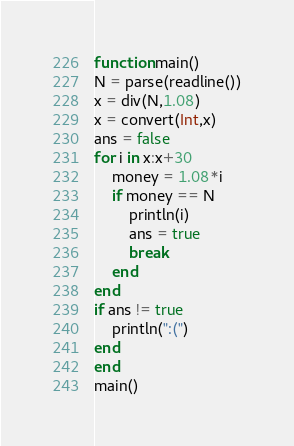<code> <loc_0><loc_0><loc_500><loc_500><_Julia_>
function main()
N = parse(readline())
x = div(N,1.08)
x = convert(Int,x)
ans = false
for i in x:x+30
    money = 1.08*i
    if money == N
        println(i)
        ans = true
        break
    end
end
if ans != true
    println(":(")
end
end
main()</code> 